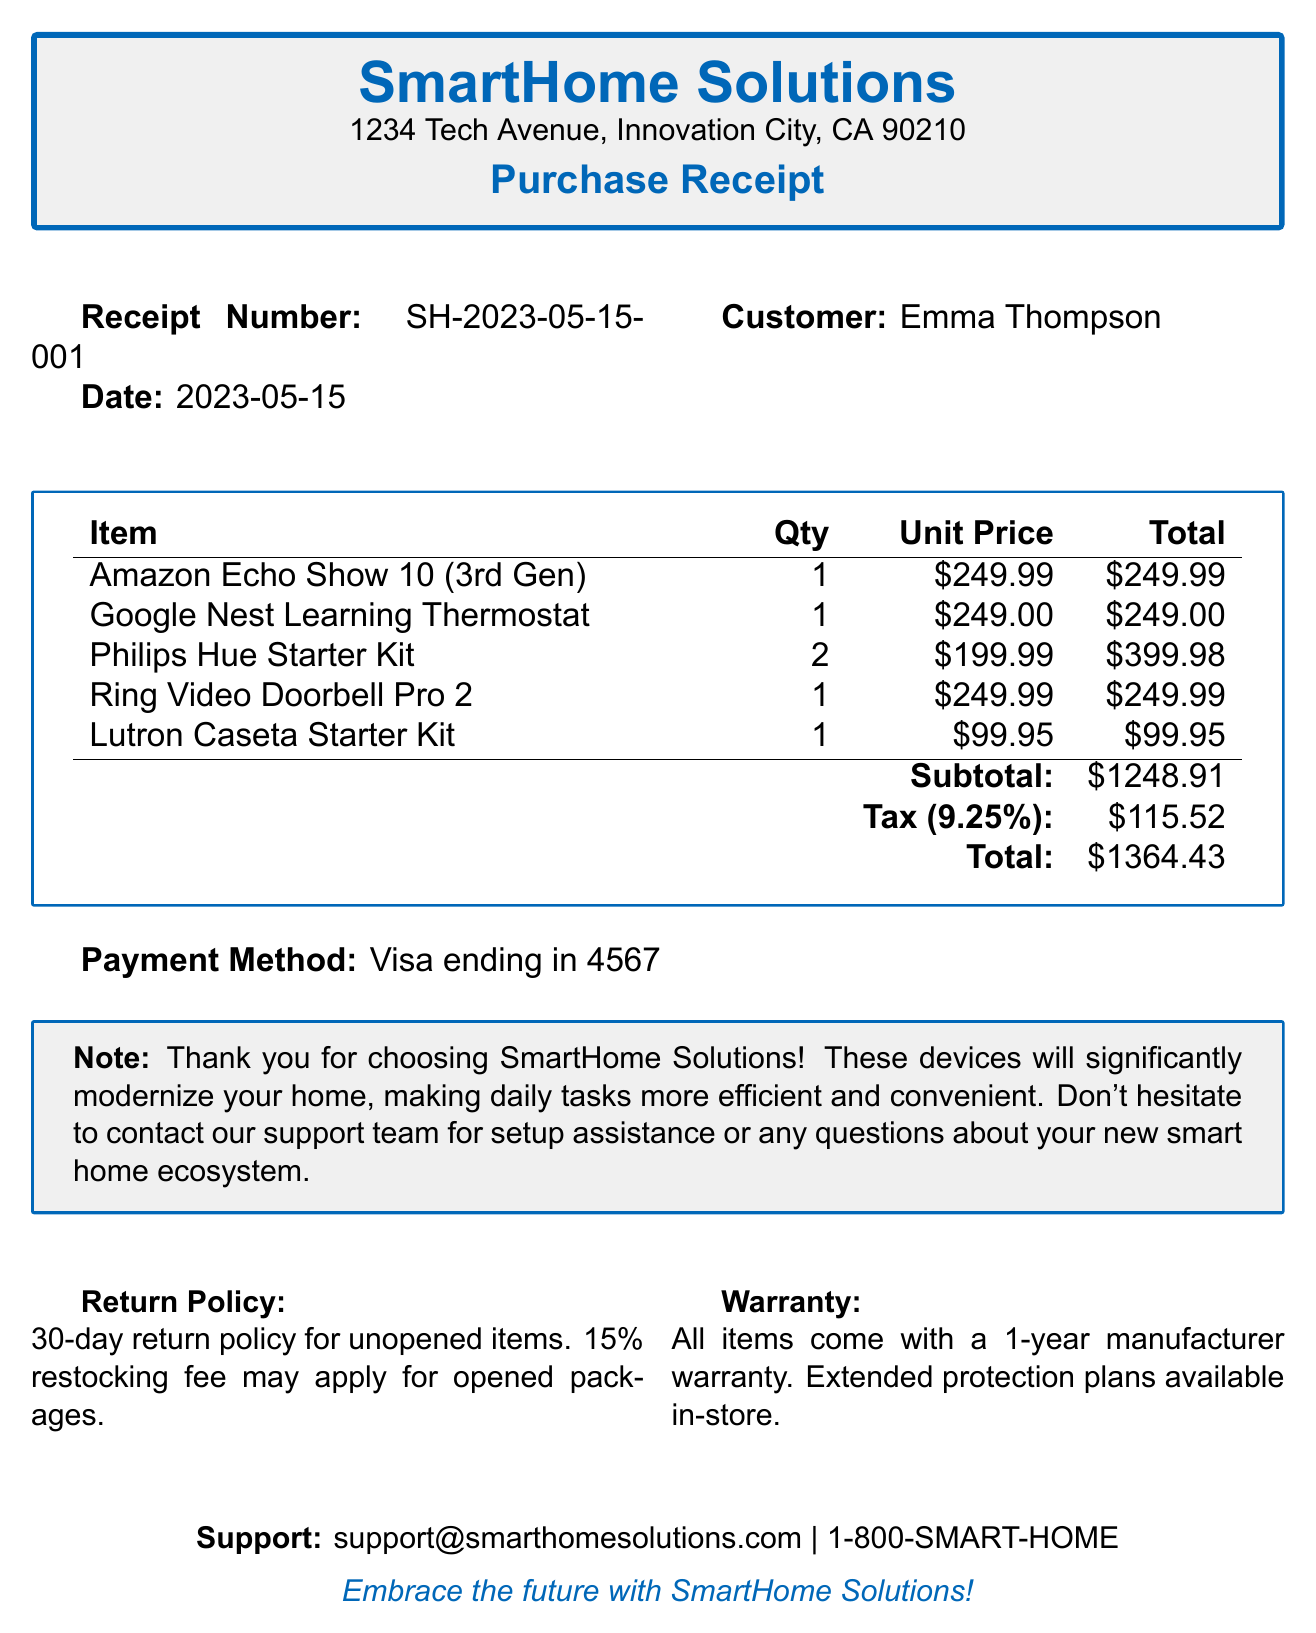What is the receipt number? The receipt number is a unique identifier for the transaction listed in the document, which is SH-2023-05-15-001.
Answer: SH-2023-05-15-001 Who is the customer? The customer name is presented in the document, which is Emma Thompson.
Answer: Emma Thompson What is the total amount spent? The total amount is the final amount due after tax and is listed as $1364.43.
Answer: $1364.43 How many Philips Hue bulbs were purchased? The number of Philips Hue bulbs can be found in the items section of the document, indicating they were purchased in a starter kit with a total of 2 bulbs.
Answer: 2 What is the warranty period for the items? The warranty information states that all items come with a 1-year manufacturer warranty.
Answer: 1 year What is the tax rate applied? The tax rate is specified in the document at 9.25%.
Answer: 9.25% What payment method was used? The payment method indicates how the transaction was completed, which was through Visa.
Answer: Visa ending in 4567 What is the return policy duration? The return policy duration for unopened items is mentioned in the document as 30 days.
Answer: 30-day What assistance is offered for setup? The document includes a note indicating that setup assistance is available from the support team.
Answer: Support team for setup assistance 